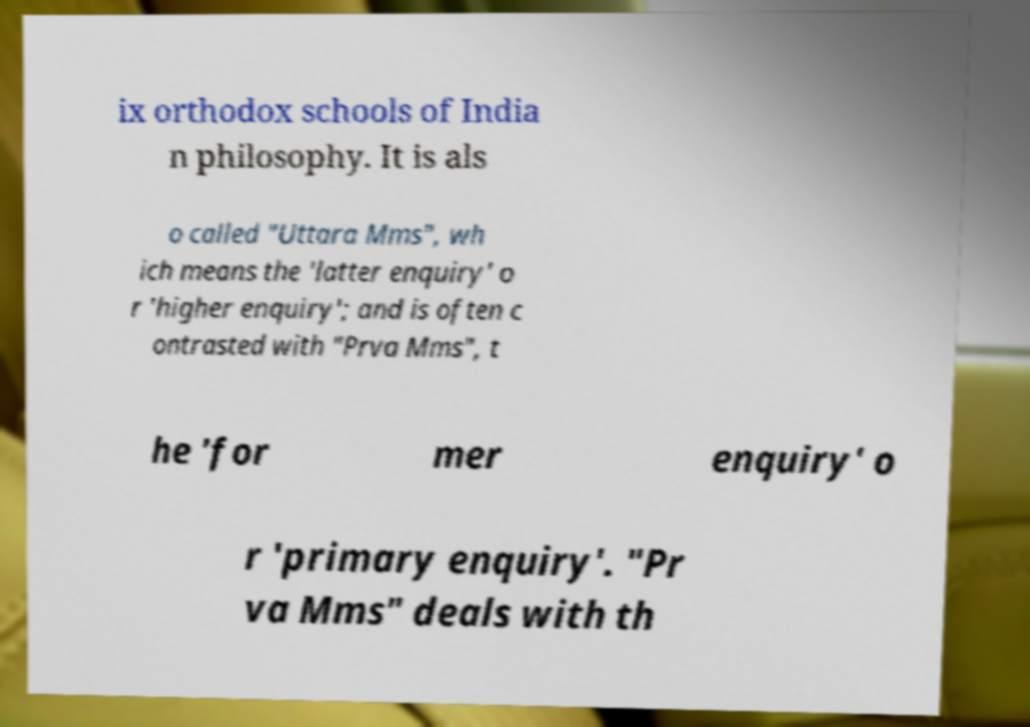What messages or text are displayed in this image? I need them in a readable, typed format. ix orthodox schools of India n philosophy. It is als o called "Uttara Mms", wh ich means the 'latter enquiry' o r 'higher enquiry'; and is often c ontrasted with "Prva Mms", t he 'for mer enquiry' o r 'primary enquiry'. "Pr va Mms" deals with th 